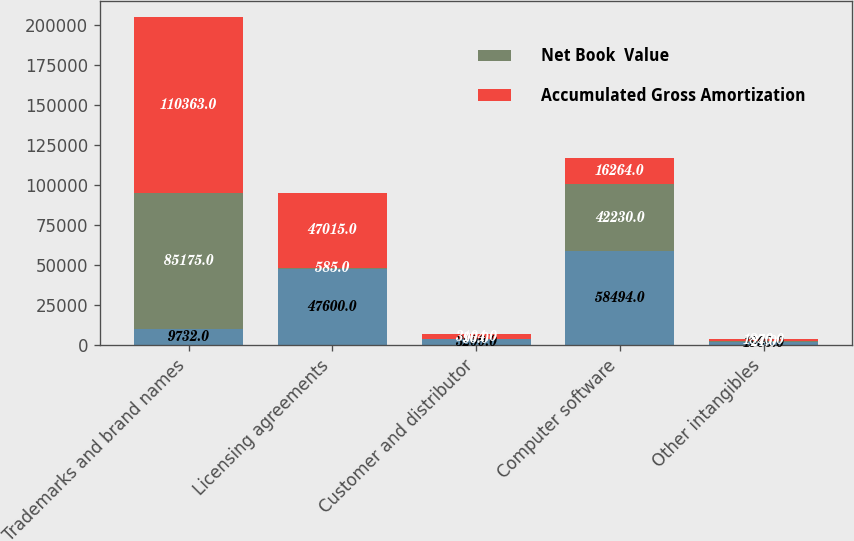Convert chart. <chart><loc_0><loc_0><loc_500><loc_500><stacked_bar_chart><ecel><fcel>Trademarks and brand names<fcel>Licensing agreements<fcel>Customer and distributor<fcel>Computer software<fcel>Other intangibles<nl><fcel>nan<fcel>9732<fcel>47600<fcel>3200<fcel>58494<fcel>1900<nl><fcel>Net Book  Value<fcel>85175<fcel>585<fcel>96<fcel>42230<fcel>24<nl><fcel>Accumulated Gross Amortization<fcel>110363<fcel>47015<fcel>3104<fcel>16264<fcel>1876<nl></chart> 